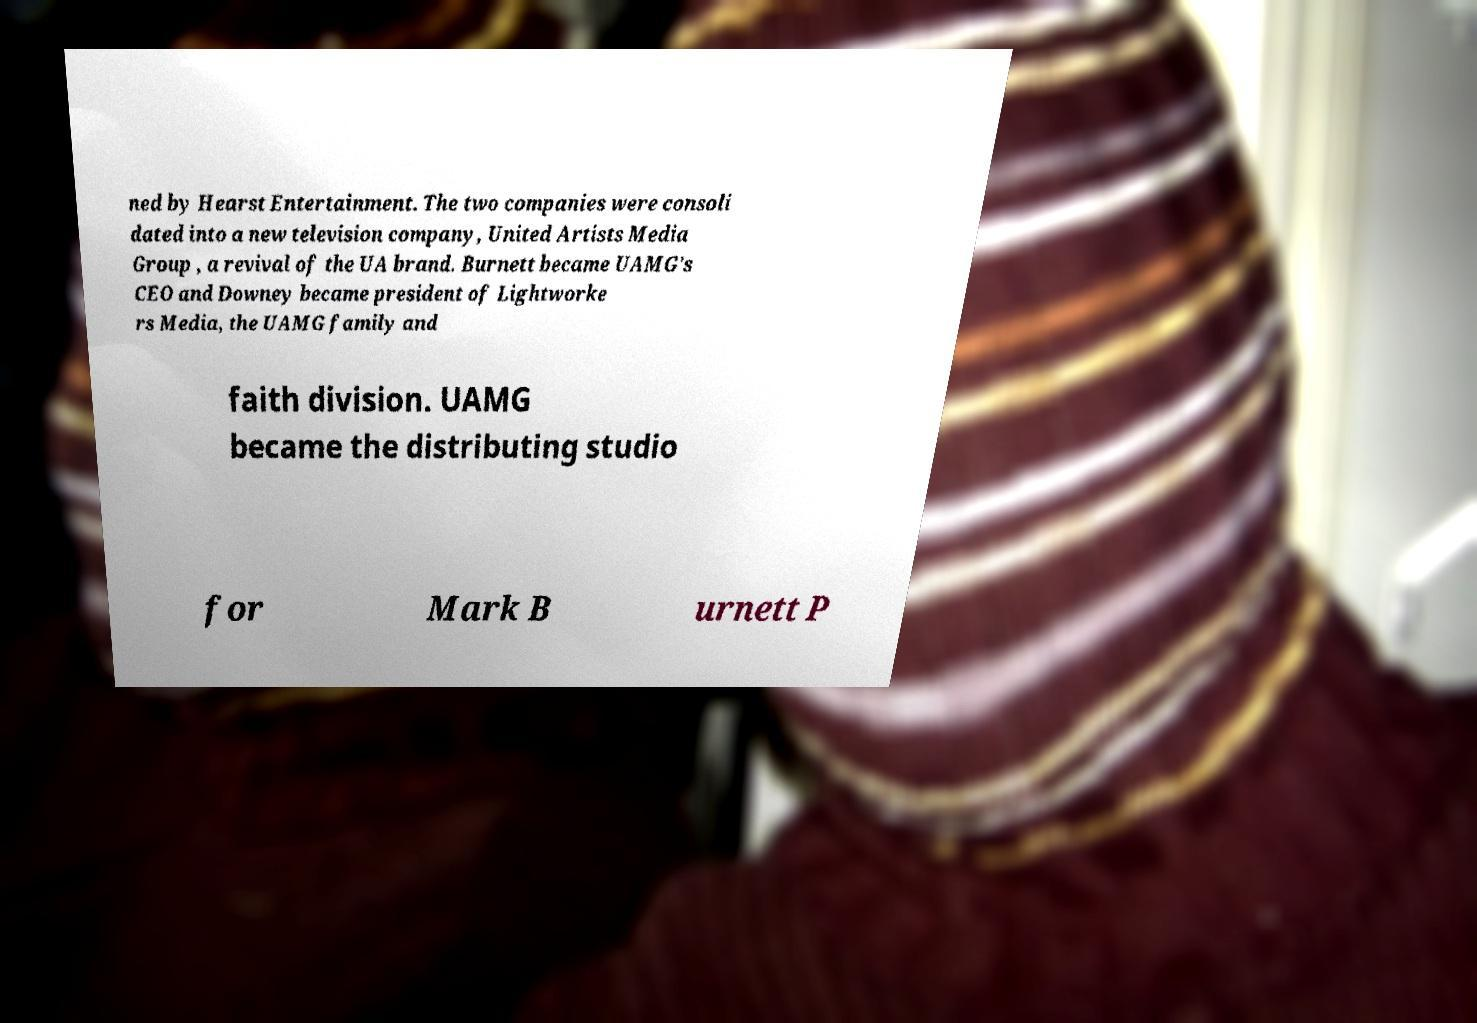For documentation purposes, I need the text within this image transcribed. Could you provide that? ned by Hearst Entertainment. The two companies were consoli dated into a new television company, United Artists Media Group , a revival of the UA brand. Burnett became UAMG's CEO and Downey became president of Lightworke rs Media, the UAMG family and faith division. UAMG became the distributing studio for Mark B urnett P 